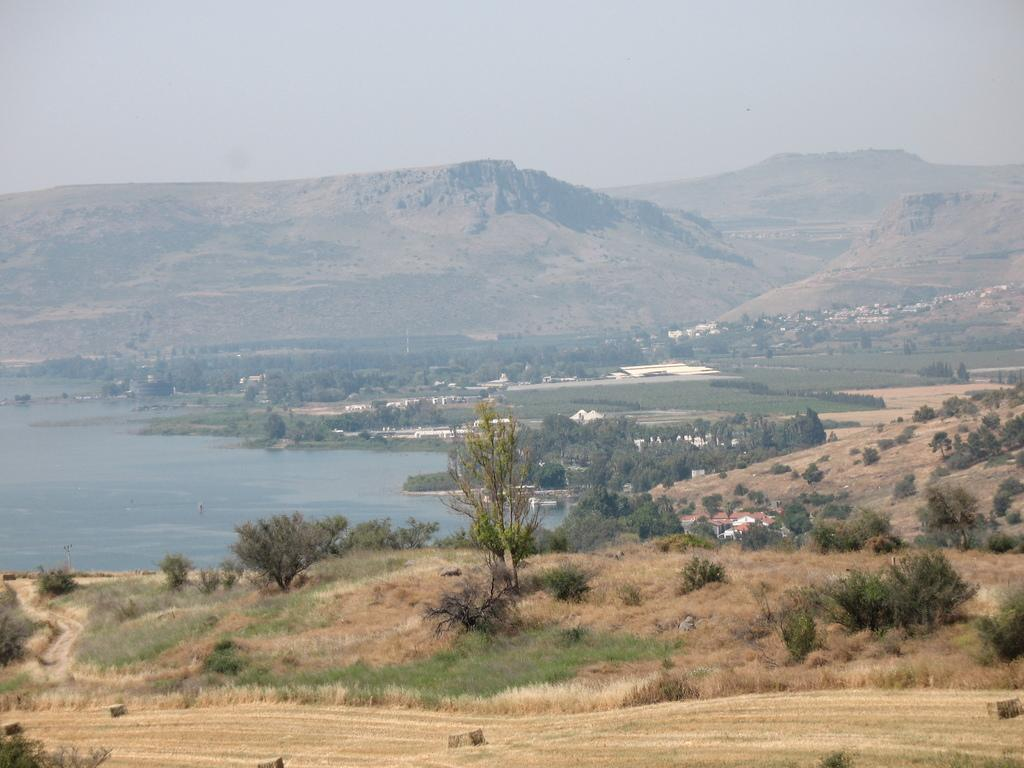What type of vegetation is in the middle of the image? There are trees in the middle of the image. What can be seen on the left side of the image? There is water on the left side of the image. What type of geographical feature is in the middle of the image? There are mountains in the middle of the image. What is visible at the top of the image? The sky is visible at the top of the image. What type of horn can be seen on the trees in the image? There are no horns present on the trees in the image. What is the current status of the water on the left side of the image? The provided facts do not mention the current status of the water, only that it is present on the left side of the image. 